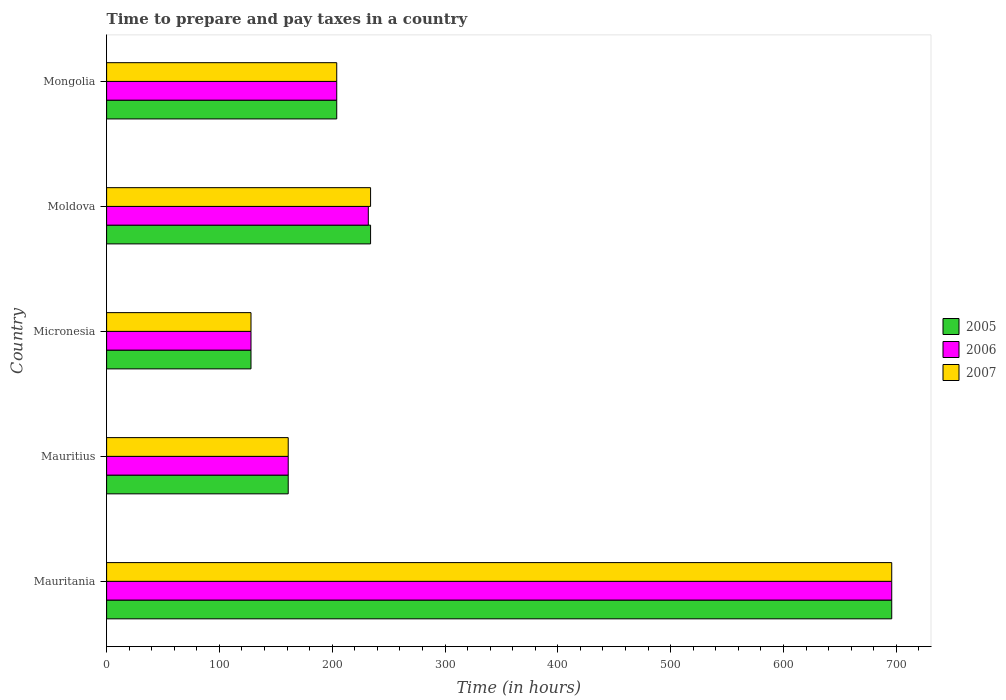How many different coloured bars are there?
Offer a terse response. 3. How many groups of bars are there?
Ensure brevity in your answer.  5. Are the number of bars on each tick of the Y-axis equal?
Your answer should be compact. Yes. How many bars are there on the 4th tick from the top?
Keep it short and to the point. 3. How many bars are there on the 3rd tick from the bottom?
Your answer should be very brief. 3. What is the label of the 5th group of bars from the top?
Your answer should be very brief. Mauritania. What is the number of hours required to prepare and pay taxes in 2007 in Mongolia?
Give a very brief answer. 204. Across all countries, what is the maximum number of hours required to prepare and pay taxes in 2005?
Your answer should be compact. 696. Across all countries, what is the minimum number of hours required to prepare and pay taxes in 2006?
Ensure brevity in your answer.  128. In which country was the number of hours required to prepare and pay taxes in 2007 maximum?
Your answer should be very brief. Mauritania. In which country was the number of hours required to prepare and pay taxes in 2006 minimum?
Provide a succinct answer. Micronesia. What is the total number of hours required to prepare and pay taxes in 2005 in the graph?
Your answer should be very brief. 1423. What is the difference between the number of hours required to prepare and pay taxes in 2007 in Mauritania and that in Mauritius?
Keep it short and to the point. 535. What is the difference between the number of hours required to prepare and pay taxes in 2007 in Moldova and the number of hours required to prepare and pay taxes in 2005 in Mauritania?
Your answer should be compact. -462. What is the average number of hours required to prepare and pay taxes in 2005 per country?
Provide a short and direct response. 284.6. What is the difference between the number of hours required to prepare and pay taxes in 2006 and number of hours required to prepare and pay taxes in 2007 in Mauritius?
Offer a terse response. 0. What is the ratio of the number of hours required to prepare and pay taxes in 2006 in Mauritania to that in Mauritius?
Offer a very short reply. 4.32. Is the number of hours required to prepare and pay taxes in 2007 in Mauritius less than that in Moldova?
Your answer should be compact. Yes. Is the difference between the number of hours required to prepare and pay taxes in 2006 in Mauritius and Micronesia greater than the difference between the number of hours required to prepare and pay taxes in 2007 in Mauritius and Micronesia?
Provide a succinct answer. No. What is the difference between the highest and the second highest number of hours required to prepare and pay taxes in 2007?
Your answer should be very brief. 462. What is the difference between the highest and the lowest number of hours required to prepare and pay taxes in 2005?
Provide a short and direct response. 568. How many bars are there?
Your response must be concise. 15. Are all the bars in the graph horizontal?
Offer a very short reply. Yes. How many countries are there in the graph?
Your response must be concise. 5. Does the graph contain any zero values?
Your answer should be compact. No. How many legend labels are there?
Offer a terse response. 3. How are the legend labels stacked?
Offer a terse response. Vertical. What is the title of the graph?
Ensure brevity in your answer.  Time to prepare and pay taxes in a country. Does "2011" appear as one of the legend labels in the graph?
Offer a terse response. No. What is the label or title of the X-axis?
Make the answer very short. Time (in hours). What is the label or title of the Y-axis?
Your response must be concise. Country. What is the Time (in hours) of 2005 in Mauritania?
Ensure brevity in your answer.  696. What is the Time (in hours) in 2006 in Mauritania?
Offer a very short reply. 696. What is the Time (in hours) in 2007 in Mauritania?
Offer a very short reply. 696. What is the Time (in hours) of 2005 in Mauritius?
Keep it short and to the point. 161. What is the Time (in hours) of 2006 in Mauritius?
Provide a short and direct response. 161. What is the Time (in hours) of 2007 in Mauritius?
Your response must be concise. 161. What is the Time (in hours) of 2005 in Micronesia?
Give a very brief answer. 128. What is the Time (in hours) of 2006 in Micronesia?
Your response must be concise. 128. What is the Time (in hours) of 2007 in Micronesia?
Ensure brevity in your answer.  128. What is the Time (in hours) of 2005 in Moldova?
Provide a succinct answer. 234. What is the Time (in hours) of 2006 in Moldova?
Offer a very short reply. 232. What is the Time (in hours) in 2007 in Moldova?
Keep it short and to the point. 234. What is the Time (in hours) of 2005 in Mongolia?
Your answer should be very brief. 204. What is the Time (in hours) of 2006 in Mongolia?
Provide a succinct answer. 204. What is the Time (in hours) of 2007 in Mongolia?
Provide a short and direct response. 204. Across all countries, what is the maximum Time (in hours) of 2005?
Offer a very short reply. 696. Across all countries, what is the maximum Time (in hours) in 2006?
Offer a very short reply. 696. Across all countries, what is the maximum Time (in hours) of 2007?
Provide a succinct answer. 696. Across all countries, what is the minimum Time (in hours) of 2005?
Keep it short and to the point. 128. Across all countries, what is the minimum Time (in hours) in 2006?
Your answer should be compact. 128. Across all countries, what is the minimum Time (in hours) of 2007?
Keep it short and to the point. 128. What is the total Time (in hours) of 2005 in the graph?
Your answer should be compact. 1423. What is the total Time (in hours) of 2006 in the graph?
Keep it short and to the point. 1421. What is the total Time (in hours) in 2007 in the graph?
Your answer should be compact. 1423. What is the difference between the Time (in hours) in 2005 in Mauritania and that in Mauritius?
Provide a succinct answer. 535. What is the difference between the Time (in hours) of 2006 in Mauritania and that in Mauritius?
Provide a succinct answer. 535. What is the difference between the Time (in hours) of 2007 in Mauritania and that in Mauritius?
Offer a very short reply. 535. What is the difference between the Time (in hours) in 2005 in Mauritania and that in Micronesia?
Your answer should be very brief. 568. What is the difference between the Time (in hours) of 2006 in Mauritania and that in Micronesia?
Keep it short and to the point. 568. What is the difference between the Time (in hours) in 2007 in Mauritania and that in Micronesia?
Provide a short and direct response. 568. What is the difference between the Time (in hours) in 2005 in Mauritania and that in Moldova?
Your answer should be very brief. 462. What is the difference between the Time (in hours) of 2006 in Mauritania and that in Moldova?
Give a very brief answer. 464. What is the difference between the Time (in hours) in 2007 in Mauritania and that in Moldova?
Offer a very short reply. 462. What is the difference between the Time (in hours) of 2005 in Mauritania and that in Mongolia?
Offer a very short reply. 492. What is the difference between the Time (in hours) of 2006 in Mauritania and that in Mongolia?
Ensure brevity in your answer.  492. What is the difference between the Time (in hours) of 2007 in Mauritania and that in Mongolia?
Ensure brevity in your answer.  492. What is the difference between the Time (in hours) in 2005 in Mauritius and that in Micronesia?
Your answer should be compact. 33. What is the difference between the Time (in hours) of 2005 in Mauritius and that in Moldova?
Keep it short and to the point. -73. What is the difference between the Time (in hours) in 2006 in Mauritius and that in Moldova?
Your answer should be very brief. -71. What is the difference between the Time (in hours) in 2007 in Mauritius and that in Moldova?
Make the answer very short. -73. What is the difference between the Time (in hours) in 2005 in Mauritius and that in Mongolia?
Give a very brief answer. -43. What is the difference between the Time (in hours) in 2006 in Mauritius and that in Mongolia?
Offer a very short reply. -43. What is the difference between the Time (in hours) in 2007 in Mauritius and that in Mongolia?
Make the answer very short. -43. What is the difference between the Time (in hours) of 2005 in Micronesia and that in Moldova?
Your answer should be compact. -106. What is the difference between the Time (in hours) in 2006 in Micronesia and that in Moldova?
Make the answer very short. -104. What is the difference between the Time (in hours) in 2007 in Micronesia and that in Moldova?
Make the answer very short. -106. What is the difference between the Time (in hours) of 2005 in Micronesia and that in Mongolia?
Make the answer very short. -76. What is the difference between the Time (in hours) in 2006 in Micronesia and that in Mongolia?
Your response must be concise. -76. What is the difference between the Time (in hours) of 2007 in Micronesia and that in Mongolia?
Your response must be concise. -76. What is the difference between the Time (in hours) in 2005 in Moldova and that in Mongolia?
Your answer should be very brief. 30. What is the difference between the Time (in hours) in 2007 in Moldova and that in Mongolia?
Offer a very short reply. 30. What is the difference between the Time (in hours) in 2005 in Mauritania and the Time (in hours) in 2006 in Mauritius?
Your answer should be compact. 535. What is the difference between the Time (in hours) of 2005 in Mauritania and the Time (in hours) of 2007 in Mauritius?
Give a very brief answer. 535. What is the difference between the Time (in hours) in 2006 in Mauritania and the Time (in hours) in 2007 in Mauritius?
Make the answer very short. 535. What is the difference between the Time (in hours) of 2005 in Mauritania and the Time (in hours) of 2006 in Micronesia?
Offer a terse response. 568. What is the difference between the Time (in hours) in 2005 in Mauritania and the Time (in hours) in 2007 in Micronesia?
Give a very brief answer. 568. What is the difference between the Time (in hours) of 2006 in Mauritania and the Time (in hours) of 2007 in Micronesia?
Offer a very short reply. 568. What is the difference between the Time (in hours) in 2005 in Mauritania and the Time (in hours) in 2006 in Moldova?
Your response must be concise. 464. What is the difference between the Time (in hours) of 2005 in Mauritania and the Time (in hours) of 2007 in Moldova?
Keep it short and to the point. 462. What is the difference between the Time (in hours) in 2006 in Mauritania and the Time (in hours) in 2007 in Moldova?
Give a very brief answer. 462. What is the difference between the Time (in hours) in 2005 in Mauritania and the Time (in hours) in 2006 in Mongolia?
Your response must be concise. 492. What is the difference between the Time (in hours) in 2005 in Mauritania and the Time (in hours) in 2007 in Mongolia?
Make the answer very short. 492. What is the difference between the Time (in hours) of 2006 in Mauritania and the Time (in hours) of 2007 in Mongolia?
Your response must be concise. 492. What is the difference between the Time (in hours) in 2005 in Mauritius and the Time (in hours) in 2006 in Micronesia?
Give a very brief answer. 33. What is the difference between the Time (in hours) in 2005 in Mauritius and the Time (in hours) in 2007 in Micronesia?
Provide a succinct answer. 33. What is the difference between the Time (in hours) of 2005 in Mauritius and the Time (in hours) of 2006 in Moldova?
Make the answer very short. -71. What is the difference between the Time (in hours) in 2005 in Mauritius and the Time (in hours) in 2007 in Moldova?
Offer a very short reply. -73. What is the difference between the Time (in hours) of 2006 in Mauritius and the Time (in hours) of 2007 in Moldova?
Give a very brief answer. -73. What is the difference between the Time (in hours) in 2005 in Mauritius and the Time (in hours) in 2006 in Mongolia?
Make the answer very short. -43. What is the difference between the Time (in hours) in 2005 in Mauritius and the Time (in hours) in 2007 in Mongolia?
Provide a succinct answer. -43. What is the difference between the Time (in hours) in 2006 in Mauritius and the Time (in hours) in 2007 in Mongolia?
Keep it short and to the point. -43. What is the difference between the Time (in hours) of 2005 in Micronesia and the Time (in hours) of 2006 in Moldova?
Give a very brief answer. -104. What is the difference between the Time (in hours) in 2005 in Micronesia and the Time (in hours) in 2007 in Moldova?
Provide a succinct answer. -106. What is the difference between the Time (in hours) in 2006 in Micronesia and the Time (in hours) in 2007 in Moldova?
Provide a succinct answer. -106. What is the difference between the Time (in hours) of 2005 in Micronesia and the Time (in hours) of 2006 in Mongolia?
Offer a terse response. -76. What is the difference between the Time (in hours) in 2005 in Micronesia and the Time (in hours) in 2007 in Mongolia?
Provide a succinct answer. -76. What is the difference between the Time (in hours) of 2006 in Micronesia and the Time (in hours) of 2007 in Mongolia?
Provide a succinct answer. -76. What is the difference between the Time (in hours) of 2005 in Moldova and the Time (in hours) of 2006 in Mongolia?
Make the answer very short. 30. What is the difference between the Time (in hours) of 2005 in Moldova and the Time (in hours) of 2007 in Mongolia?
Your answer should be very brief. 30. What is the difference between the Time (in hours) of 2006 in Moldova and the Time (in hours) of 2007 in Mongolia?
Offer a very short reply. 28. What is the average Time (in hours) of 2005 per country?
Give a very brief answer. 284.6. What is the average Time (in hours) of 2006 per country?
Your answer should be very brief. 284.2. What is the average Time (in hours) in 2007 per country?
Make the answer very short. 284.6. What is the difference between the Time (in hours) in 2005 and Time (in hours) in 2006 in Mauritania?
Your response must be concise. 0. What is the difference between the Time (in hours) in 2005 and Time (in hours) in 2007 in Mauritania?
Provide a succinct answer. 0. What is the difference between the Time (in hours) in 2006 and Time (in hours) in 2007 in Mauritania?
Your answer should be compact. 0. What is the difference between the Time (in hours) in 2005 and Time (in hours) in 2006 in Mauritius?
Make the answer very short. 0. What is the difference between the Time (in hours) of 2005 and Time (in hours) of 2007 in Mauritius?
Offer a terse response. 0. What is the difference between the Time (in hours) of 2006 and Time (in hours) of 2007 in Mauritius?
Ensure brevity in your answer.  0. What is the difference between the Time (in hours) in 2005 and Time (in hours) in 2006 in Moldova?
Your answer should be compact. 2. What is the difference between the Time (in hours) in 2005 and Time (in hours) in 2007 in Moldova?
Keep it short and to the point. 0. What is the difference between the Time (in hours) of 2006 and Time (in hours) of 2007 in Moldova?
Keep it short and to the point. -2. What is the difference between the Time (in hours) of 2006 and Time (in hours) of 2007 in Mongolia?
Give a very brief answer. 0. What is the ratio of the Time (in hours) in 2005 in Mauritania to that in Mauritius?
Give a very brief answer. 4.32. What is the ratio of the Time (in hours) in 2006 in Mauritania to that in Mauritius?
Offer a terse response. 4.32. What is the ratio of the Time (in hours) in 2007 in Mauritania to that in Mauritius?
Ensure brevity in your answer.  4.32. What is the ratio of the Time (in hours) of 2005 in Mauritania to that in Micronesia?
Your response must be concise. 5.44. What is the ratio of the Time (in hours) of 2006 in Mauritania to that in Micronesia?
Your response must be concise. 5.44. What is the ratio of the Time (in hours) in 2007 in Mauritania to that in Micronesia?
Give a very brief answer. 5.44. What is the ratio of the Time (in hours) of 2005 in Mauritania to that in Moldova?
Make the answer very short. 2.97. What is the ratio of the Time (in hours) in 2007 in Mauritania to that in Moldova?
Your answer should be compact. 2.97. What is the ratio of the Time (in hours) in 2005 in Mauritania to that in Mongolia?
Ensure brevity in your answer.  3.41. What is the ratio of the Time (in hours) of 2006 in Mauritania to that in Mongolia?
Give a very brief answer. 3.41. What is the ratio of the Time (in hours) in 2007 in Mauritania to that in Mongolia?
Provide a short and direct response. 3.41. What is the ratio of the Time (in hours) of 2005 in Mauritius to that in Micronesia?
Your answer should be very brief. 1.26. What is the ratio of the Time (in hours) in 2006 in Mauritius to that in Micronesia?
Offer a terse response. 1.26. What is the ratio of the Time (in hours) in 2007 in Mauritius to that in Micronesia?
Offer a terse response. 1.26. What is the ratio of the Time (in hours) in 2005 in Mauritius to that in Moldova?
Keep it short and to the point. 0.69. What is the ratio of the Time (in hours) in 2006 in Mauritius to that in Moldova?
Your answer should be very brief. 0.69. What is the ratio of the Time (in hours) of 2007 in Mauritius to that in Moldova?
Give a very brief answer. 0.69. What is the ratio of the Time (in hours) of 2005 in Mauritius to that in Mongolia?
Your response must be concise. 0.79. What is the ratio of the Time (in hours) in 2006 in Mauritius to that in Mongolia?
Keep it short and to the point. 0.79. What is the ratio of the Time (in hours) of 2007 in Mauritius to that in Mongolia?
Your answer should be compact. 0.79. What is the ratio of the Time (in hours) in 2005 in Micronesia to that in Moldova?
Provide a succinct answer. 0.55. What is the ratio of the Time (in hours) of 2006 in Micronesia to that in Moldova?
Offer a terse response. 0.55. What is the ratio of the Time (in hours) in 2007 in Micronesia to that in Moldova?
Your answer should be very brief. 0.55. What is the ratio of the Time (in hours) in 2005 in Micronesia to that in Mongolia?
Provide a succinct answer. 0.63. What is the ratio of the Time (in hours) in 2006 in Micronesia to that in Mongolia?
Your answer should be very brief. 0.63. What is the ratio of the Time (in hours) in 2007 in Micronesia to that in Mongolia?
Your response must be concise. 0.63. What is the ratio of the Time (in hours) in 2005 in Moldova to that in Mongolia?
Keep it short and to the point. 1.15. What is the ratio of the Time (in hours) in 2006 in Moldova to that in Mongolia?
Offer a very short reply. 1.14. What is the ratio of the Time (in hours) of 2007 in Moldova to that in Mongolia?
Make the answer very short. 1.15. What is the difference between the highest and the second highest Time (in hours) of 2005?
Your answer should be very brief. 462. What is the difference between the highest and the second highest Time (in hours) of 2006?
Ensure brevity in your answer.  464. What is the difference between the highest and the second highest Time (in hours) of 2007?
Provide a succinct answer. 462. What is the difference between the highest and the lowest Time (in hours) in 2005?
Your answer should be compact. 568. What is the difference between the highest and the lowest Time (in hours) in 2006?
Ensure brevity in your answer.  568. What is the difference between the highest and the lowest Time (in hours) of 2007?
Offer a very short reply. 568. 